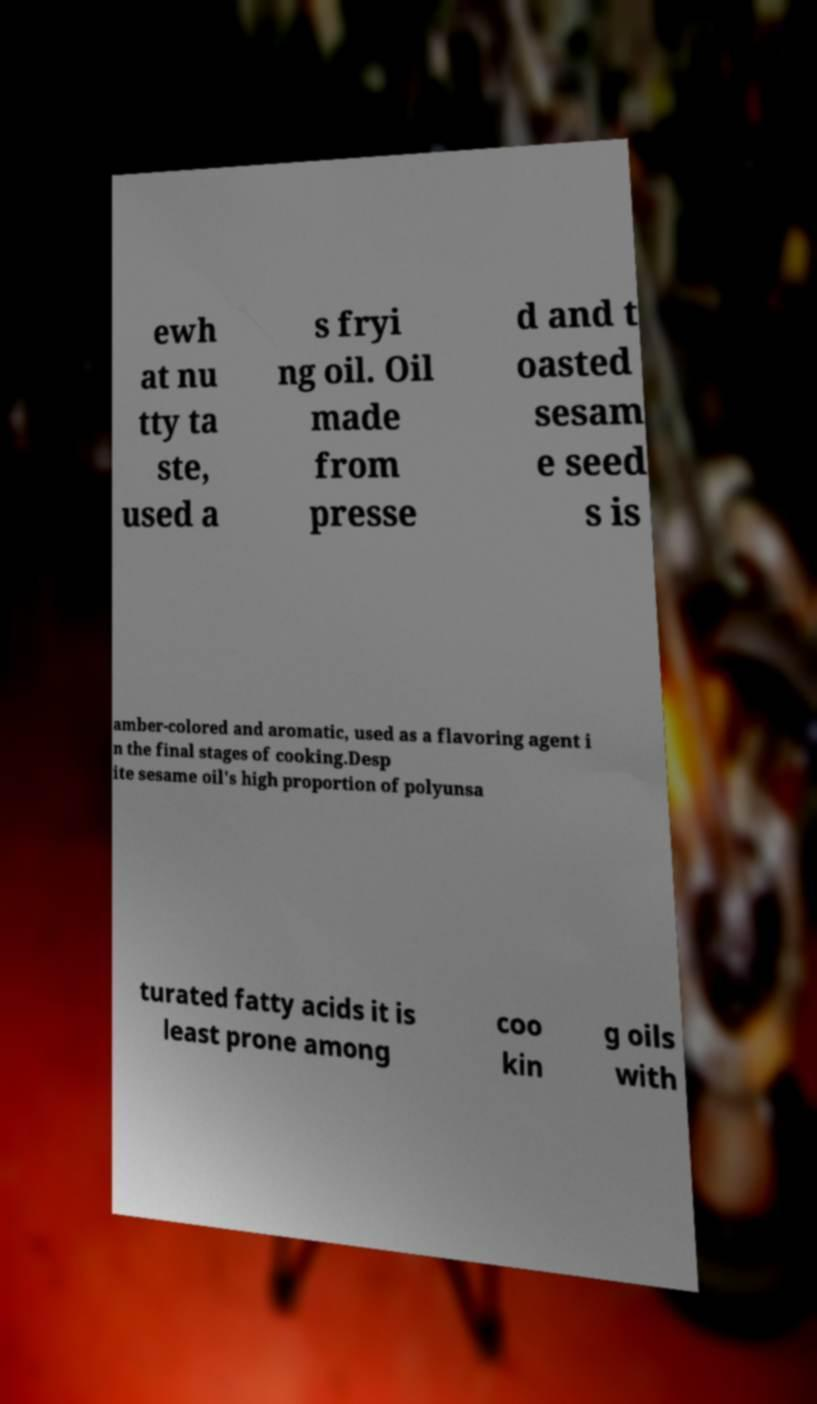Can you accurately transcribe the text from the provided image for me? ewh at nu tty ta ste, used a s fryi ng oil. Oil made from presse d and t oasted sesam e seed s is amber-colored and aromatic, used as a flavoring agent i n the final stages of cooking.Desp ite sesame oil's high proportion of polyunsa turated fatty acids it is least prone among coo kin g oils with 